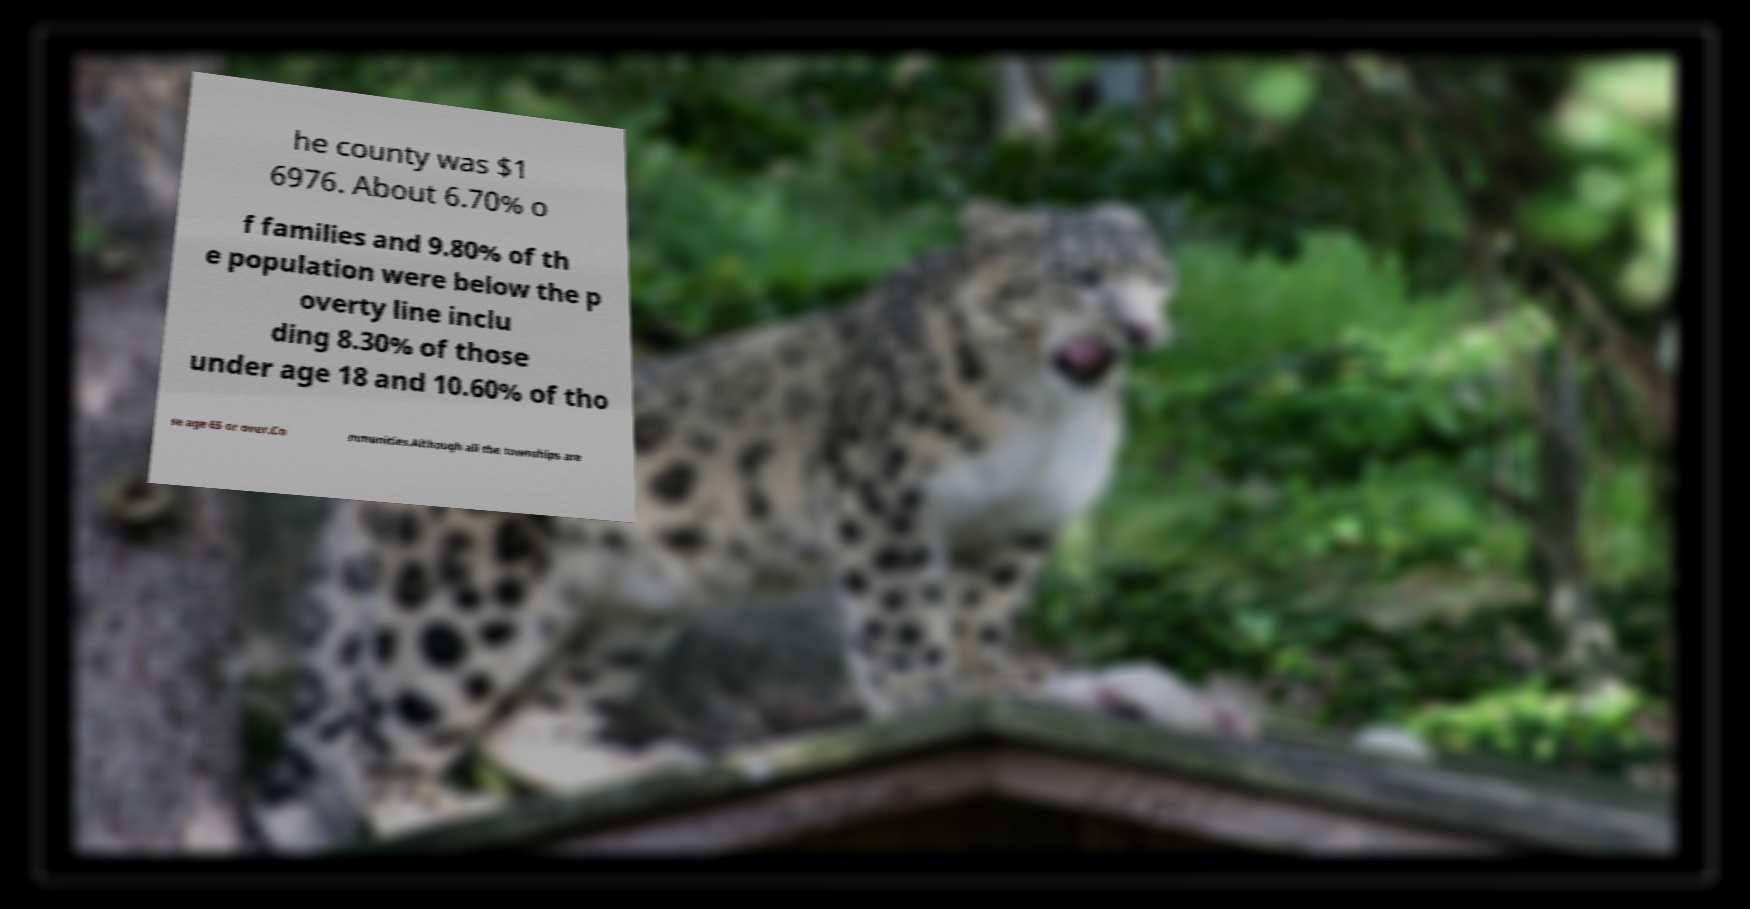For documentation purposes, I need the text within this image transcribed. Could you provide that? he county was $1 6976. About 6.70% o f families and 9.80% of th e population were below the p overty line inclu ding 8.30% of those under age 18 and 10.60% of tho se age 65 or over.Co mmunities.Although all the townships are 